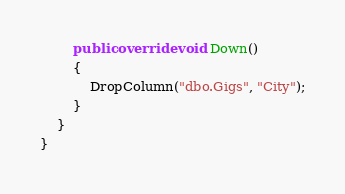Convert code to text. <code><loc_0><loc_0><loc_500><loc_500><_C#_>        public override void Down()
        {
            DropColumn("dbo.Gigs", "City");
        }
    }
}
</code> 